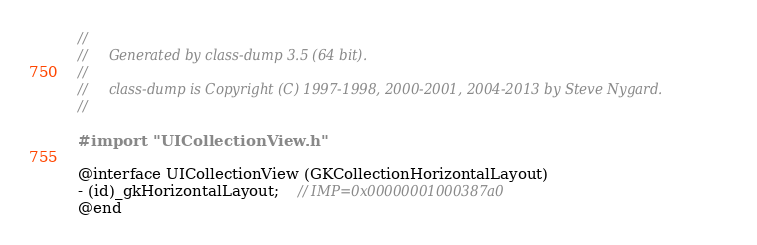<code> <loc_0><loc_0><loc_500><loc_500><_C_>//
//     Generated by class-dump 3.5 (64 bit).
//
//     class-dump is Copyright (C) 1997-1998, 2000-2001, 2004-2013 by Steve Nygard.
//

#import "UICollectionView.h"

@interface UICollectionView (GKCollectionHorizontalLayout)
- (id)_gkHorizontalLayout;	// IMP=0x00000001000387a0
@end

</code> 